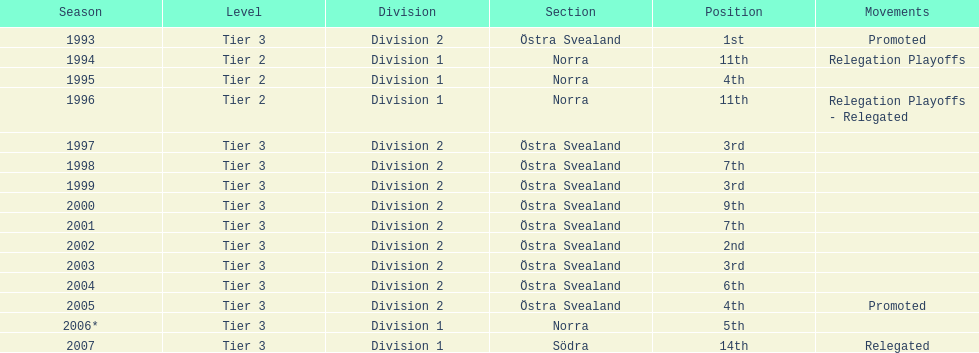When was the last time they accomplished a third-place standing before that? 1999. 